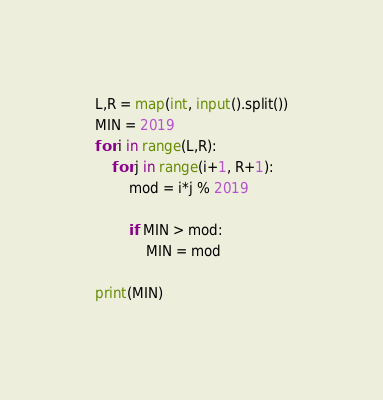<code> <loc_0><loc_0><loc_500><loc_500><_Python_>L,R = map(int, input().split())
MIN = 2019
for i in range(L,R):
    for j in range(i+1, R+1):
        mod = i*j % 2019
        
        if MIN > mod:
            MIN = mod
 
print(MIN)</code> 